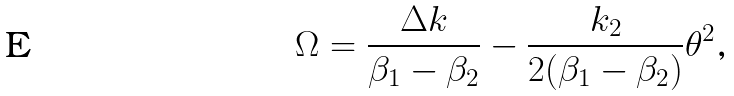<formula> <loc_0><loc_0><loc_500><loc_500>\Omega = \frac { \Delta k } { \beta _ { 1 } - \beta _ { 2 } } - \frac { k _ { 2 } } { 2 ( \beta _ { 1 } - \beta _ { 2 } ) } \theta ^ { 2 } \text {,}</formula> 